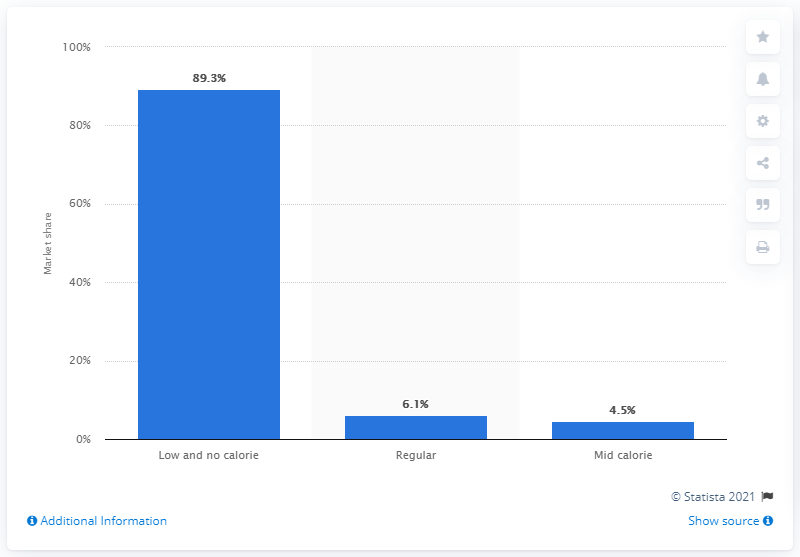Specify some key components in this picture. In 2019, regular dilutables accounted for approximately 4.5% of the total soft drink market in the UK. 